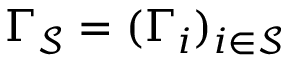<formula> <loc_0><loc_0><loc_500><loc_500>\Gamma _ { \mathcal { S } } = ( \Gamma _ { i } ) _ { i \in \mathcal { S } }</formula> 